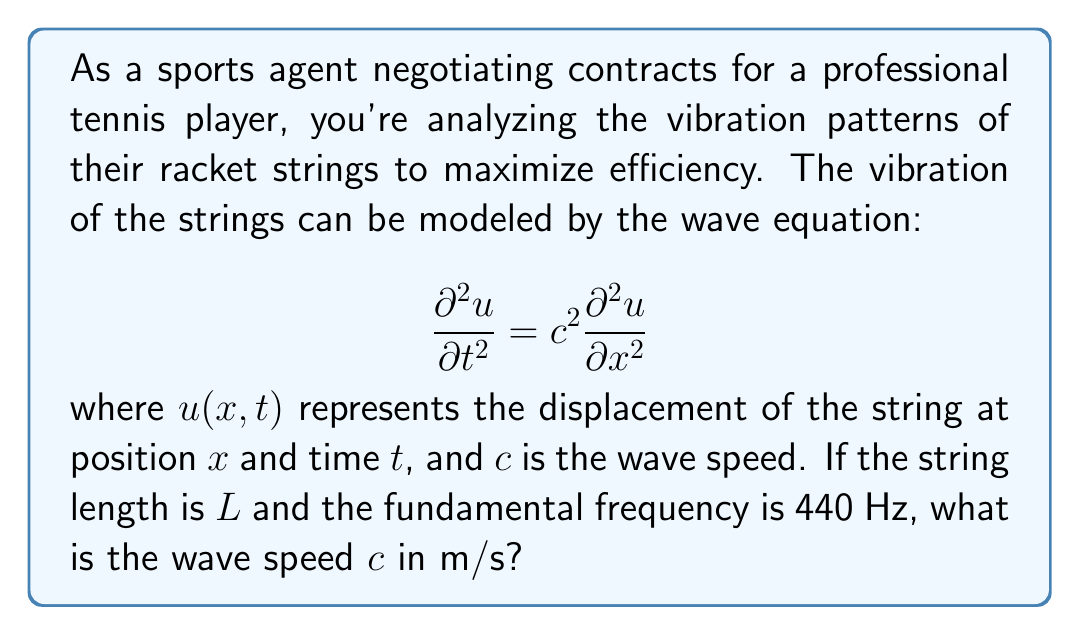Show me your answer to this math problem. Let's approach this step-by-step:

1) For a string fixed at both ends, the fundamental frequency $f_1$ is related to the string length $L$ and wave speed $c$ by the equation:

   $$f_1 = \frac{c}{2L}$$

2) We are given that $f_1 = 440$ Hz. Let's rearrange the equation to solve for $c$:

   $$c = 2Lf_1$$

3) We know $f_1$, but we don't know $L$. However, we can use a standard tennis racket string length. The main strings of a tennis racket are typically about 12 inches or 0.3048 meters long.

4) Now we can substitute our values:

   $$c = 2 \cdot 0.3048 \text{ m} \cdot 440 \text{ Hz}$$

5) Calculate:

   $$c = 0.6096 \text{ m} \cdot 440 \text{ s}^{-1} = 268.224 \text{ m/s}$$

6) Rounding to a reasonable number of significant figures, we get:

   $$c \approx 268 \text{ m/s}$$

This wave speed represents how fast vibrations travel along the tennis racket strings, which is crucial for understanding and optimizing the racket's performance.
Answer: 268 m/s 